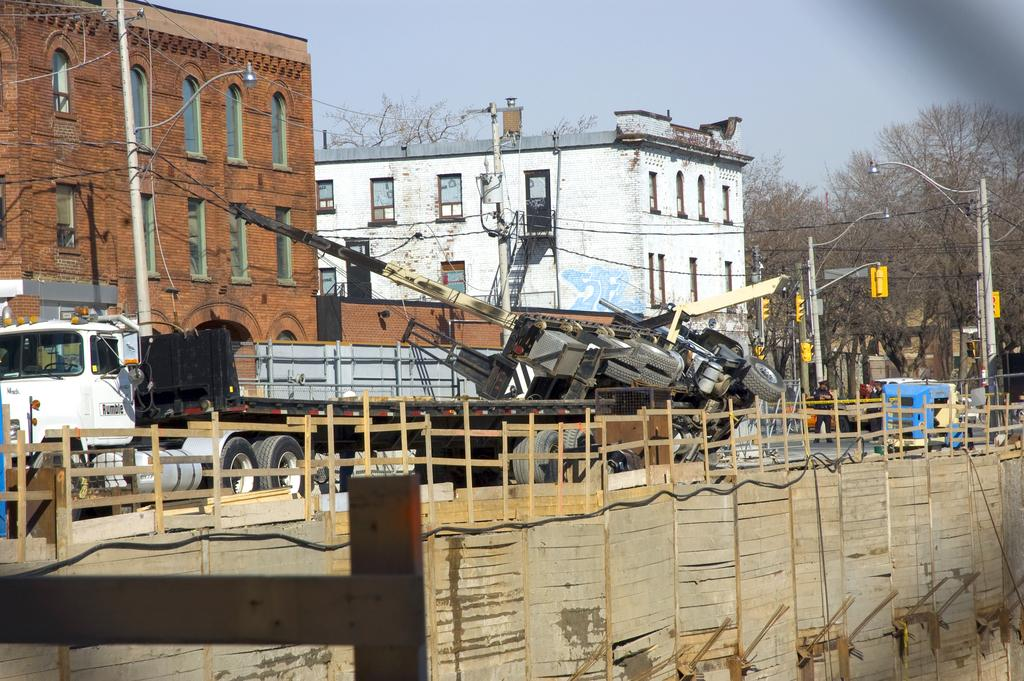What can be seen moving on the road in the image? There are vehicles on the road in the image. What type of structures are visible in the image? There are two buildings visible in the image. What type of vegetation is present in the image? There are trees in the image. What is visible at the top of the image? The sky is visible at the top of the image. Can you tell me how many visitors are sitting on the shelf in the image? There are no visitors or shelves present in the image. What type of laughter can be heard coming from the trees in the image? There is no laughter present in the image, as it features vehicles on the road, buildings, trees, and the sky. 